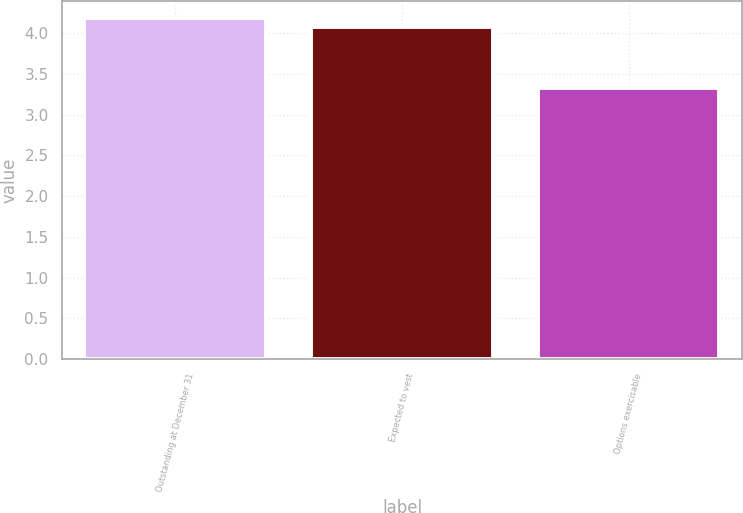Convert chart. <chart><loc_0><loc_0><loc_500><loc_500><bar_chart><fcel>Outstanding at December 31<fcel>Expected to vest<fcel>Options exercisable<nl><fcel>4.18<fcel>4.08<fcel>3.33<nl></chart> 